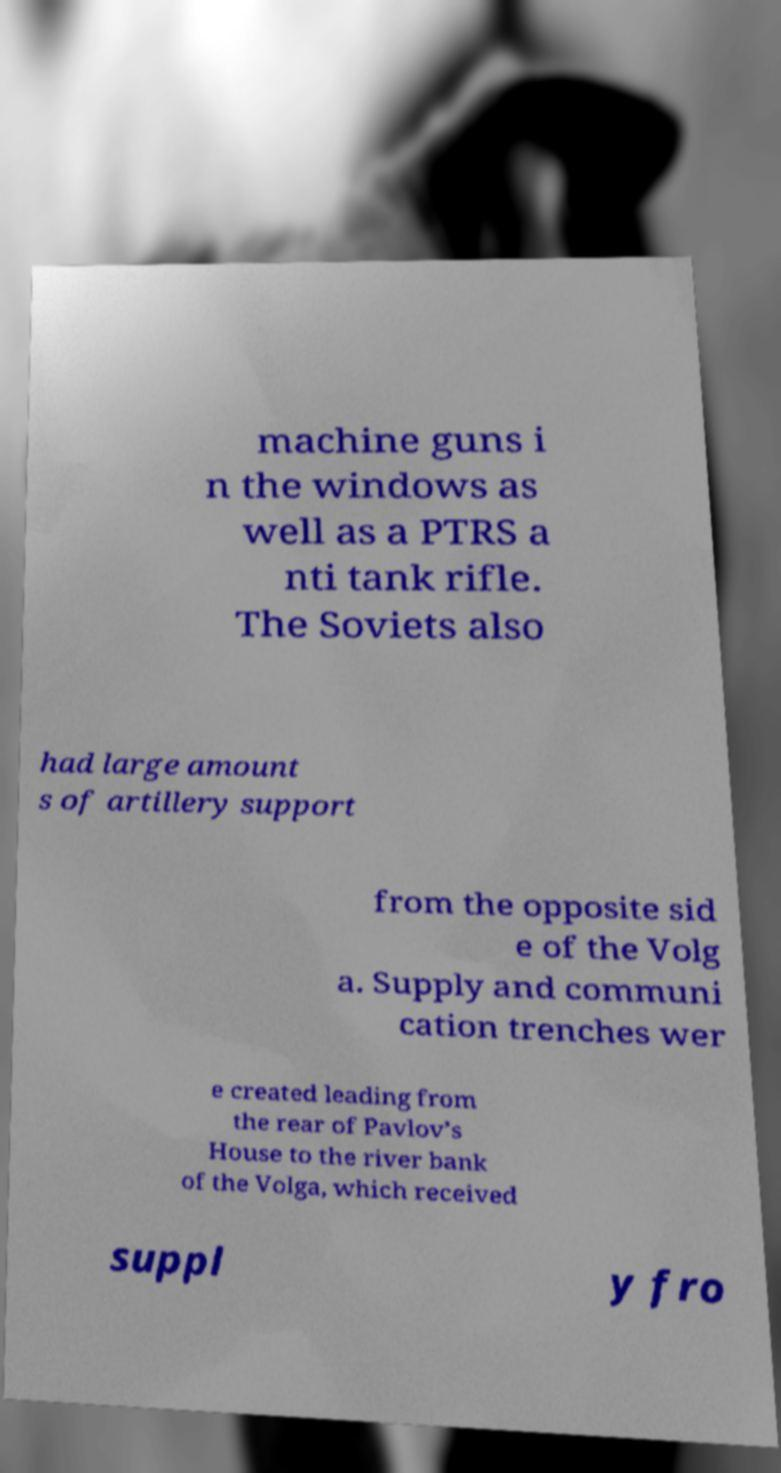I need the written content from this picture converted into text. Can you do that? machine guns i n the windows as well as a PTRS a nti tank rifle. The Soviets also had large amount s of artillery support from the opposite sid e of the Volg a. Supply and communi cation trenches wer e created leading from the rear of Pavlov’s House to the river bank of the Volga, which received suppl y fro 